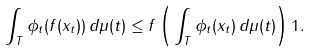Convert formula to latex. <formula><loc_0><loc_0><loc_500><loc_500>\int _ { T } \phi _ { t } ( f ( x _ { t } ) ) \, d \mu ( t ) \leq f \left ( \| \int _ { T } \phi _ { t } ( x _ { t } ) \, d \mu ( t ) \| \right ) { 1 } .</formula> 